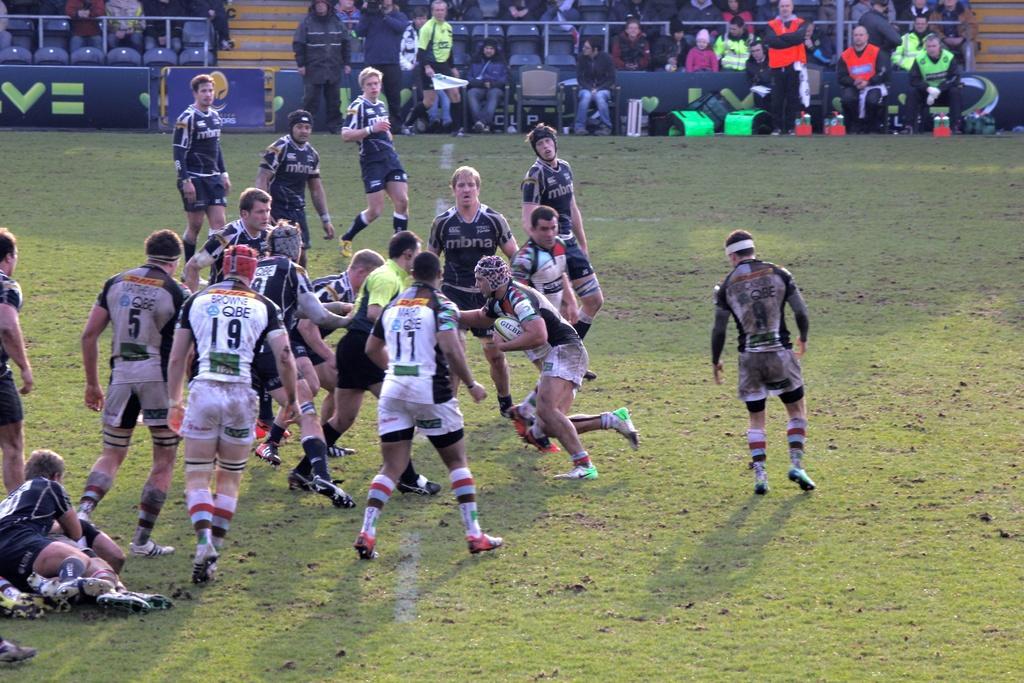How would you summarize this image in a sentence or two? In this image we can see few persons are standing and running on the ground and few persons are lying on the ground on the left side and a person is holding ball in his hands. In the background there are audience, chairs, hoardings, poles, water bottles and other objects. 